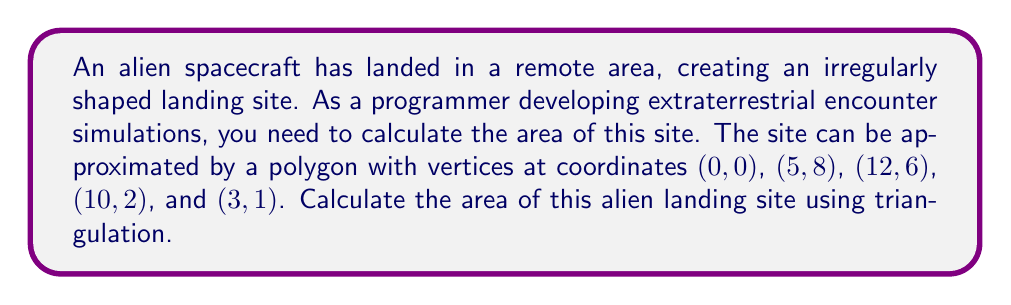Can you answer this question? To calculate the area of this irregular polygon using triangulation, we'll follow these steps:

1) Divide the polygon into triangles by connecting the vertices to a common point (e.g., the origin).

2) Calculate the area of each triangle using the formula:
   $$A = \frac{1}{2}|x_1(y_2 - y_3) + x_2(y_3 - y_1) + x_3(y_1 - y_2)|$$
   where $(x_1, y_1)$, $(x_2, y_2)$, and $(x_3, y_3)$ are the coordinates of the triangle's vertices.

3) Sum the areas of all triangles.

Let's calculate:

Triangle 1: (0, 0), (5, 8), (12, 6)
$$A_1 = \frac{1}{2}|0(8 - 6) + 5(6 - 0) + 12(0 - 8)| = 48$$

Triangle 2: (0, 0), (12, 6), (10, 2)
$$A_2 = \frac{1}{2}|0(6 - 2) + 12(2 - 0) + 10(0 - 6)| = 12$$

Triangle 3: (0, 0), (10, 2), (3, 1)
$$A_3 = \frac{1}{2}|0(2 - 1) + 10(1 - 0) + 3(0 - 2)| = 2$$

Total Area = $A_1 + A_2 + A_3 = 48 + 12 + 2 = 62$

[asy]
unitsize(10);
draw((0,0)--(5,8)--(12,6)--(10,2)--(3,1)--cycle);
label("(0,0)", (0,0), SW);
label("(5,8)", (5,8), N);
label("(12,6)", (12,6), E);
label("(10,2)", (10,2), SE);
label("(3,1)", (3,1), S);
[/asy]
Answer: 62 square units 